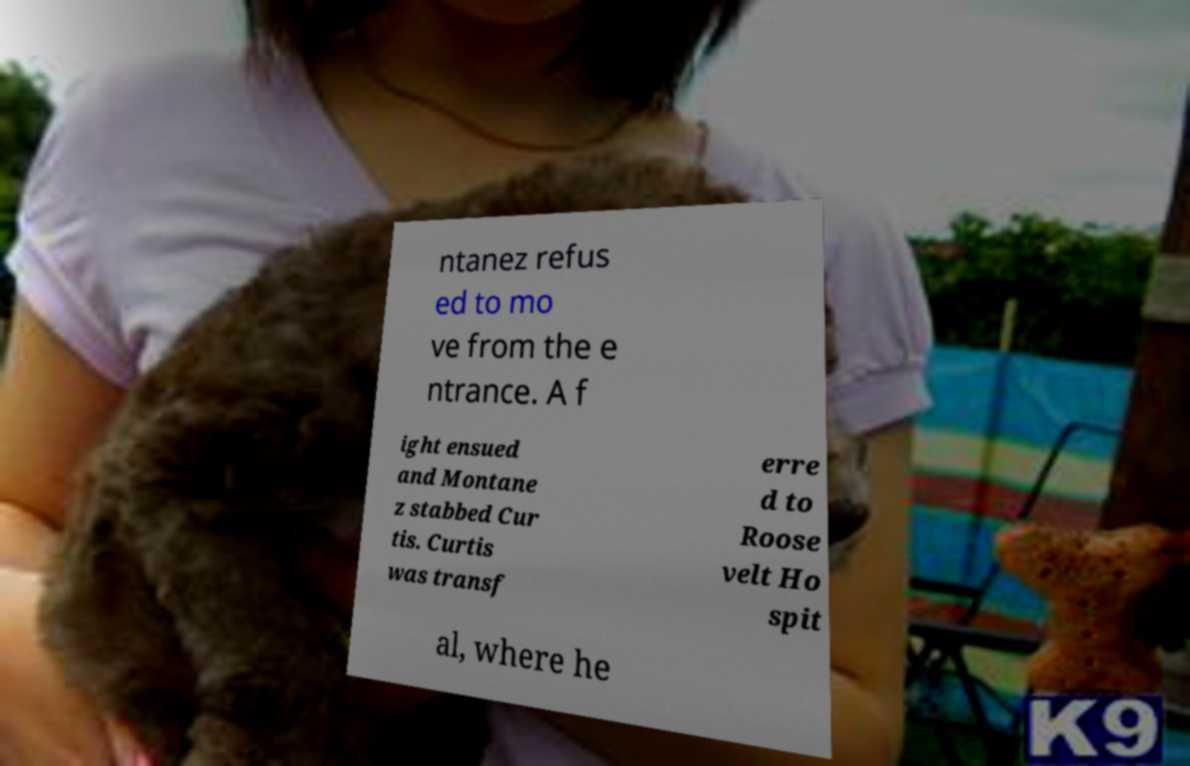There's text embedded in this image that I need extracted. Can you transcribe it verbatim? ntanez refus ed to mo ve from the e ntrance. A f ight ensued and Montane z stabbed Cur tis. Curtis was transf erre d to Roose velt Ho spit al, where he 